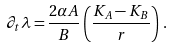Convert formula to latex. <formula><loc_0><loc_0><loc_500><loc_500>\partial _ { t } \lambda = \frac { 2 \alpha A } { B } \left ( \frac { K _ { A } - K _ { B } } { r } \right ) \, .</formula> 